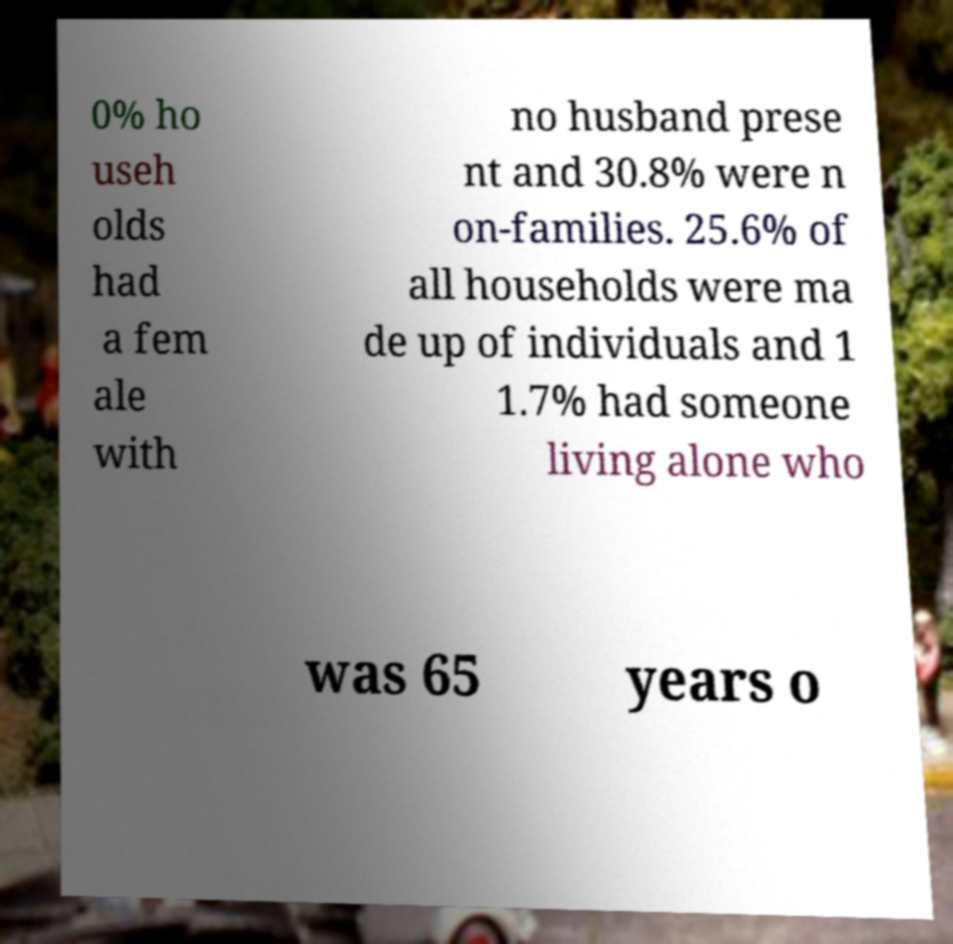I need the written content from this picture converted into text. Can you do that? 0% ho useh olds had a fem ale with no husband prese nt and 30.8% were n on-families. 25.6% of all households were ma de up of individuals and 1 1.7% had someone living alone who was 65 years o 